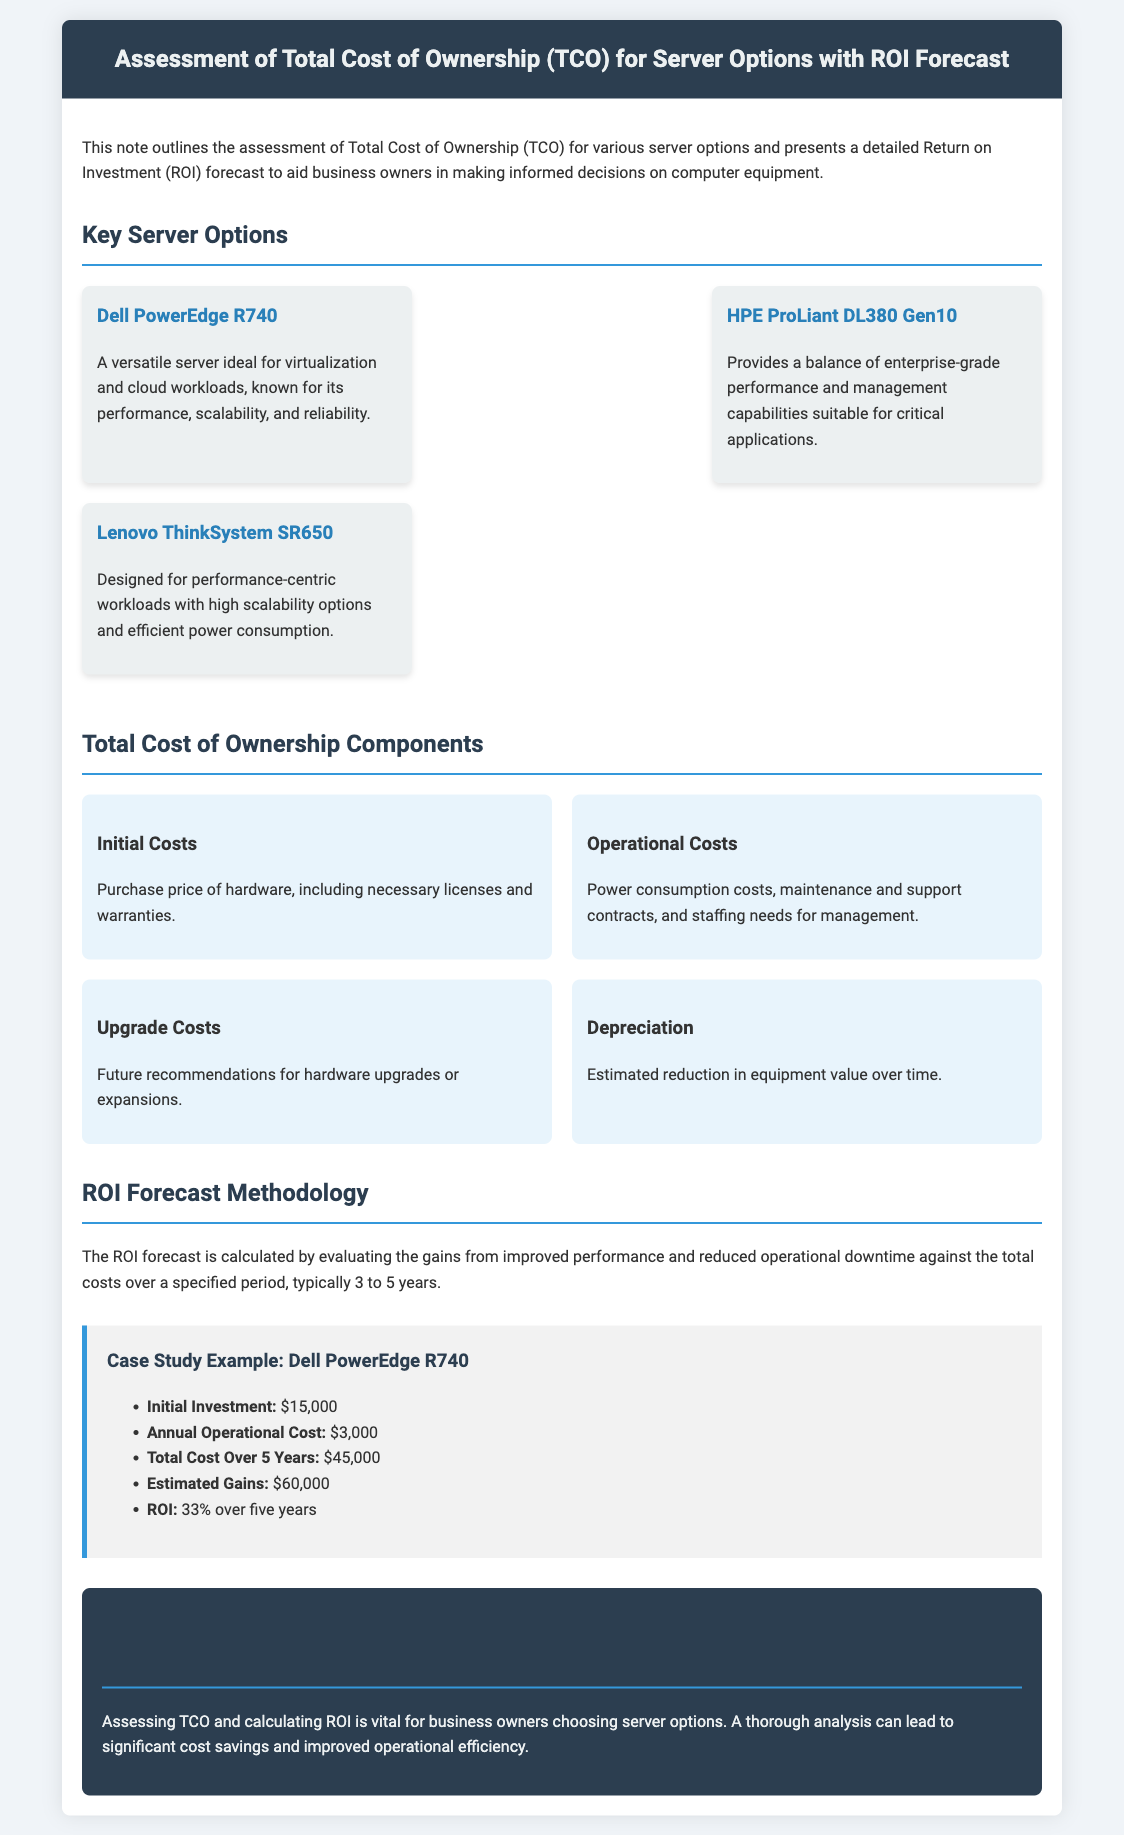what is the title of the document? The title of the document is presented in the header section of the document.
Answer: Assessment of Total Cost of Ownership (TCO) for Server Options with ROI Forecast what are the three key server options mentioned? The key server options are listed under the "Key Server Options" section.
Answer: Dell PowerEdge R740, HPE ProLiant DL380 Gen10, Lenovo ThinkSystem SR650 what is the annual operational cost for the Dell PowerEdge R740? The annual operational cost is found in the case study example section for the Dell PowerEdge R740.
Answer: $3,000 what is the estimated ROI for the Dell PowerEdge R740 over five years? The ROI is calculated in the case study example section for the Dell PowerEdge R740.
Answer: 33% how many years does the ROI forecast typically cover? The typical period for ROI forecast is mentioned in the ROI forecast methodology section.
Answer: 3 to 5 years what components are included in the total cost of ownership? The total cost of ownership components are outlined in separate sections of the document.
Answer: Initial Costs, Operational Costs, Upgrade Costs, Depreciation what is the initial investment for the Dell PowerEdge R740? The initial investment amount is specified in the case study example section for the Dell PowerEdge R740.
Answer: $15,000 what color is used for the conclusion section? The color used for the conclusion section is described in the styling details.
Answer: #2c3e50 